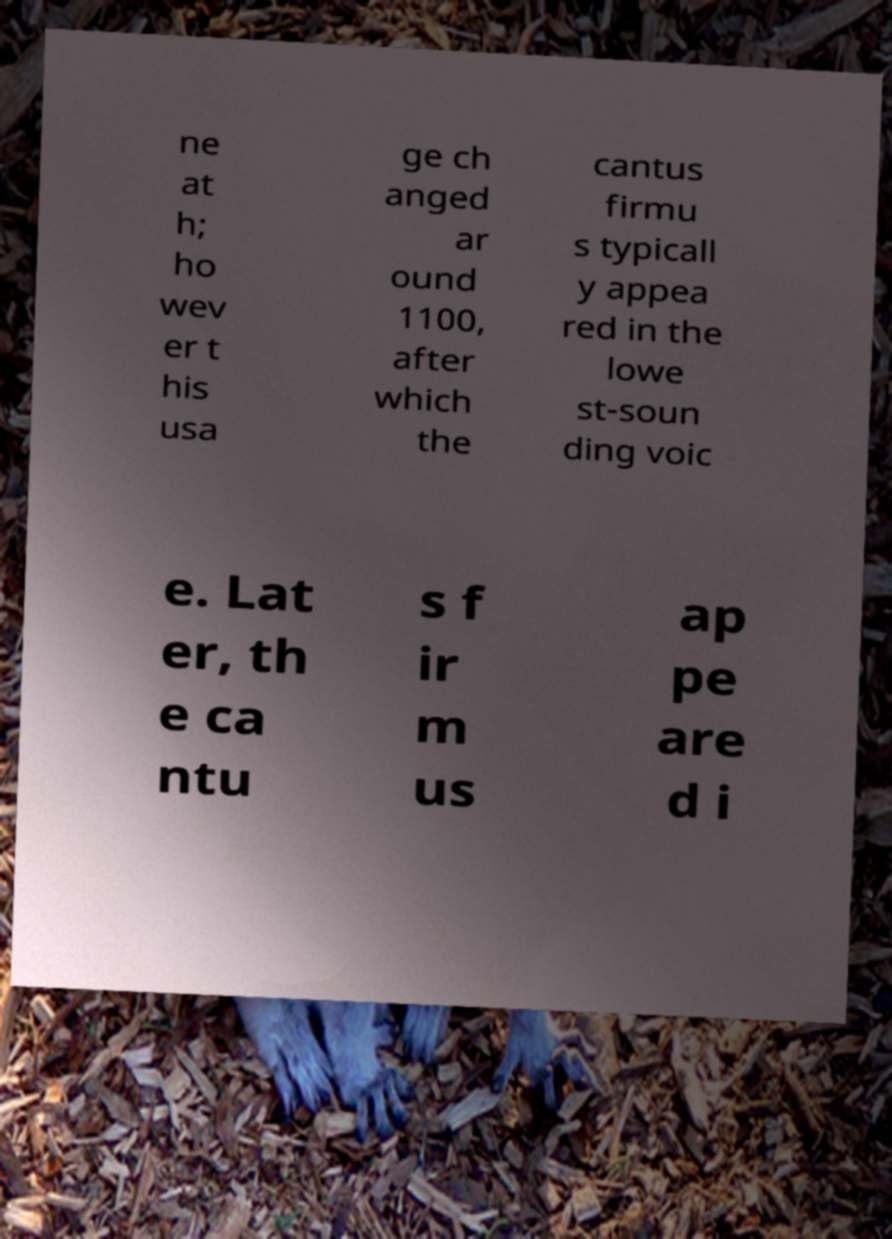Can you accurately transcribe the text from the provided image for me? ne at h; ho wev er t his usa ge ch anged ar ound 1100, after which the cantus firmu s typicall y appea red in the lowe st-soun ding voic e. Lat er, th e ca ntu s f ir m us ap pe are d i 